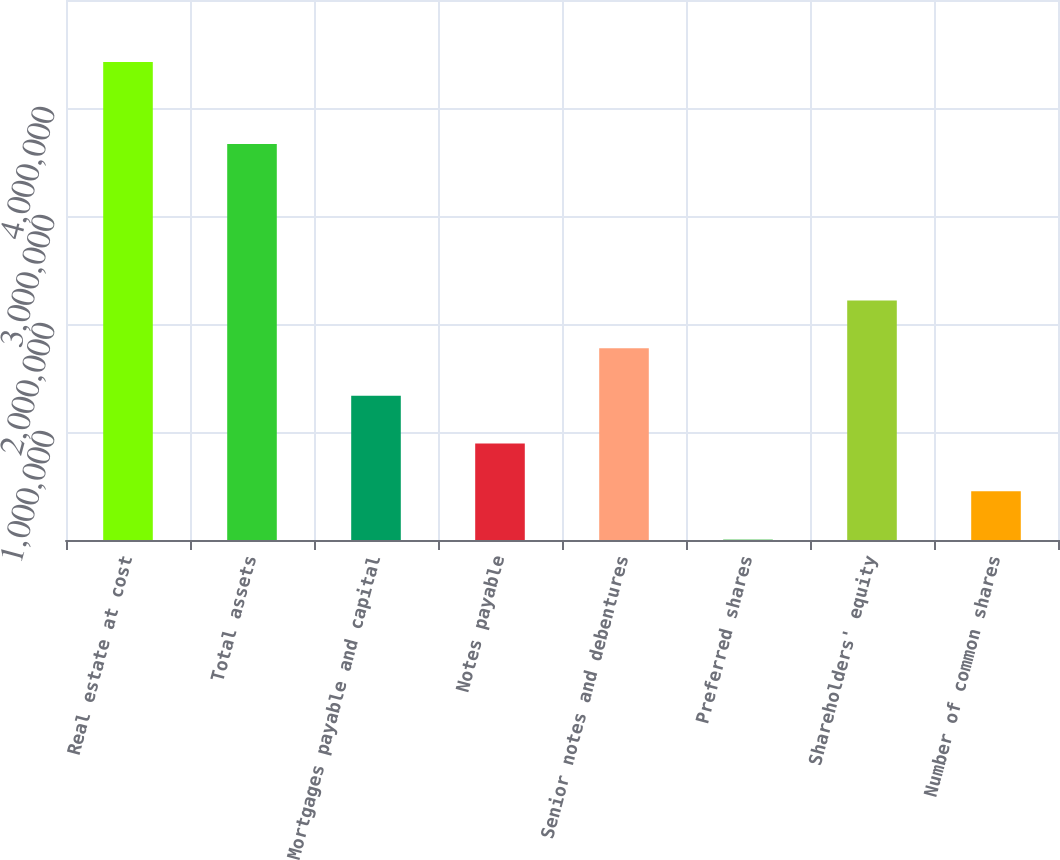Convert chart to OTSL. <chart><loc_0><loc_0><loc_500><loc_500><bar_chart><fcel>Real estate at cost<fcel>Total assets<fcel>Mortgages payable and capital<fcel>Notes payable<fcel>Senior notes and debentures<fcel>Preferred shares<fcel>Shareholders' equity<fcel>Number of common shares<nl><fcel>4.42644e+06<fcel>3.66621e+06<fcel>1.33493e+06<fcel>893286<fcel>1.77658e+06<fcel>9997<fcel>2.21822e+06<fcel>451642<nl></chart> 